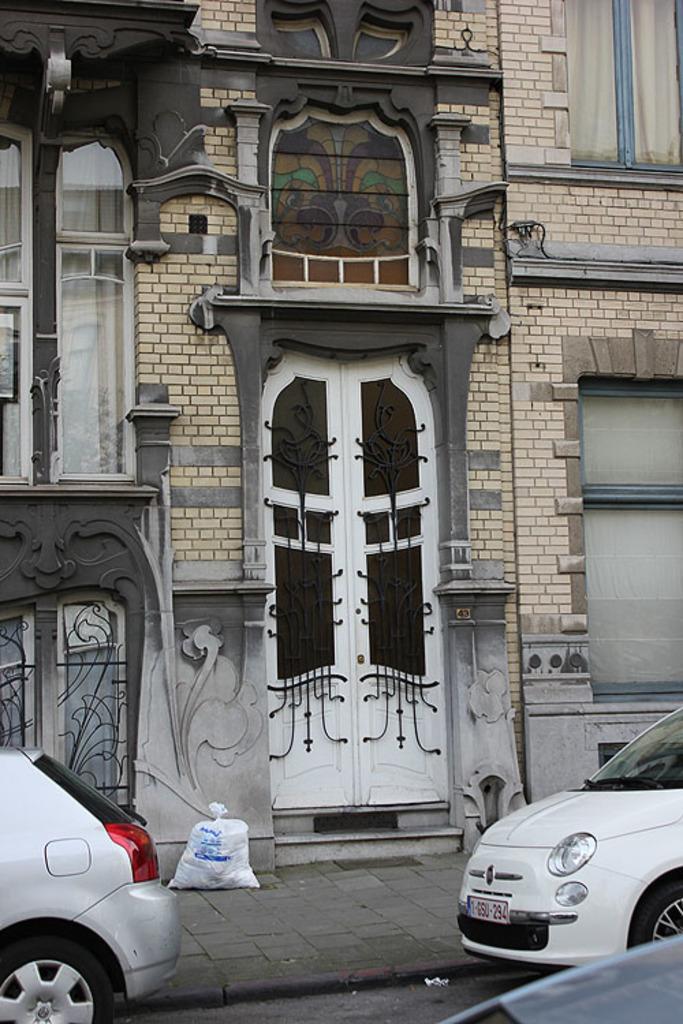In one or two sentences, can you explain what this image depicts? In this picture I can see the cars on either side of this message, in the middle there is a building with windows and doors. 